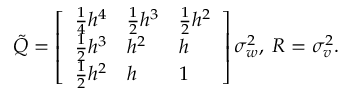Convert formula to latex. <formula><loc_0><loc_0><loc_500><loc_500>\begin{array} { r } { \tilde { Q } = \left [ \begin{array} { l l l } { \frac { 1 } { 4 } h ^ { 4 } } & { \frac { 1 } { 2 } h ^ { 3 } } & { \frac { 1 } { 2 } h ^ { 2 } } \\ { \frac { 1 } { 2 } h ^ { 3 } } & { h ^ { 2 } } & { h } \\ { \frac { 1 } { 2 } h ^ { 2 } } & { h } & { 1 } \end{array} \right ] \sigma _ { w } ^ { 2 } , \, R = \sigma _ { v } ^ { 2 } . } \end{array}</formula> 